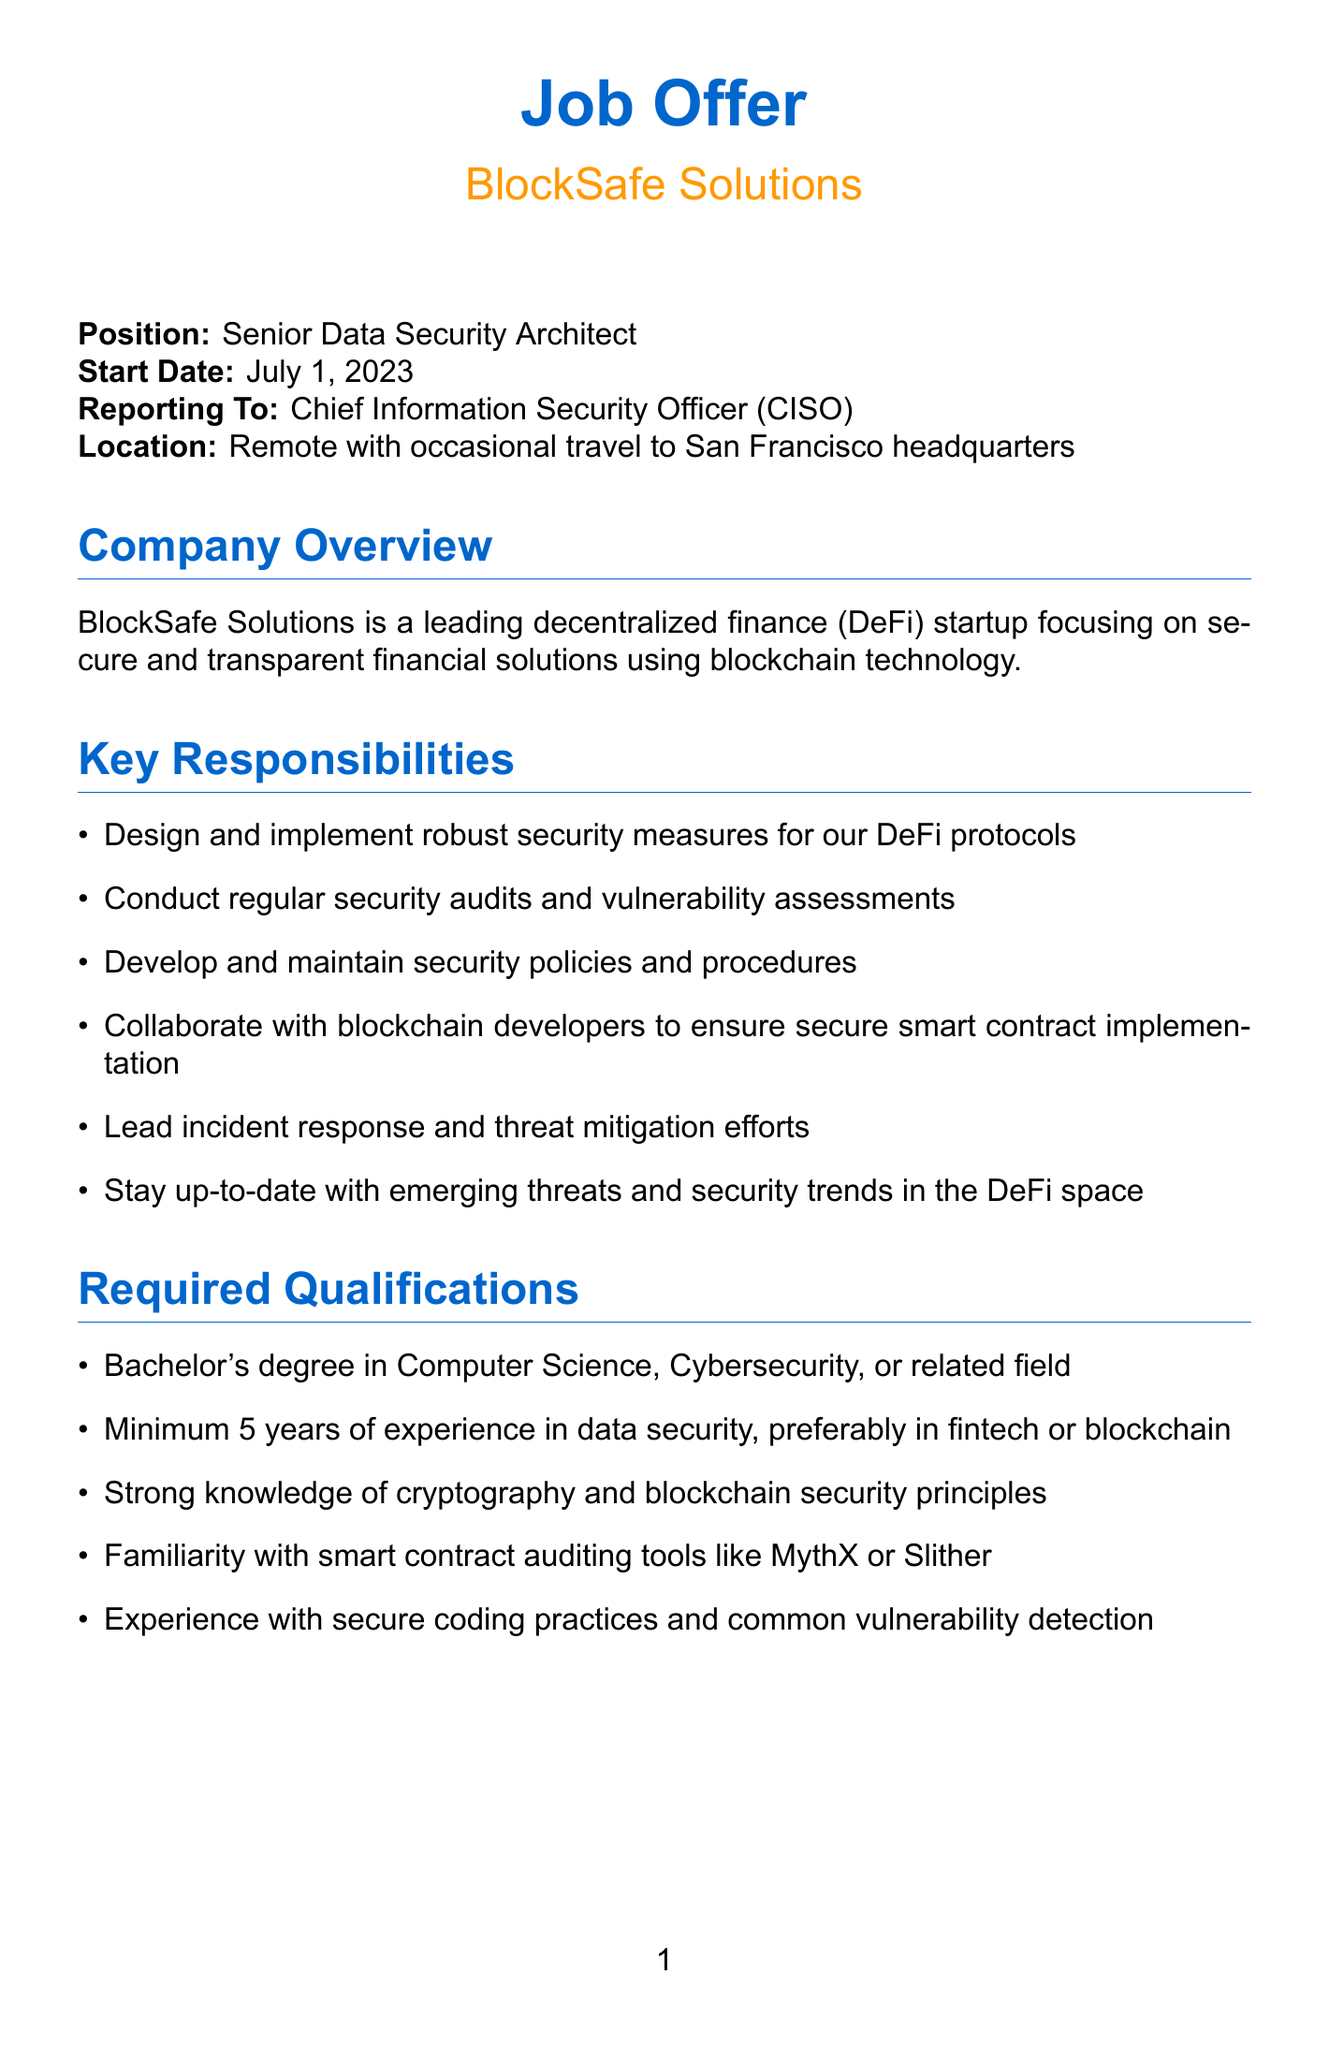What is the position title? The document specifically states the job title being offered.
Answer: Senior Data Security Architect Who is the position reporting to? The document outlines the hierarchy of the position regarding whom the candidate will report to.
Answer: Chief Information Security Officer (CISO) What is the base salary range? The compensation package presents a salary range for the position.
Answer: $150,000 - $180,000 per year How many years of experience is required? The required qualifications mention the minimum experience needed for the position.
Answer: Minimum 5 years What will the token allocation amount to? The compensation package details the allocation of tokens provided to the employee.
Answer: 50,000 BSFT tokens What is included in the benefits package? The document describes several perks and benefits provided to the employee.
Answer: Comprehensive health, dental, and vision insurance Which city will have occasional travel requirements? The job location indicates where travel may be necessary.
Answer: San Francisco What type of degree is required? The required qualifications section specifies the educational background necessary for the position.
Answer: Bachelor's degree in Computer Science, Cybersecurity, or related field What is the application process's first step? The document outlines the sequence of steps involved in the application process.
Answer: Initial phone screening with HR 